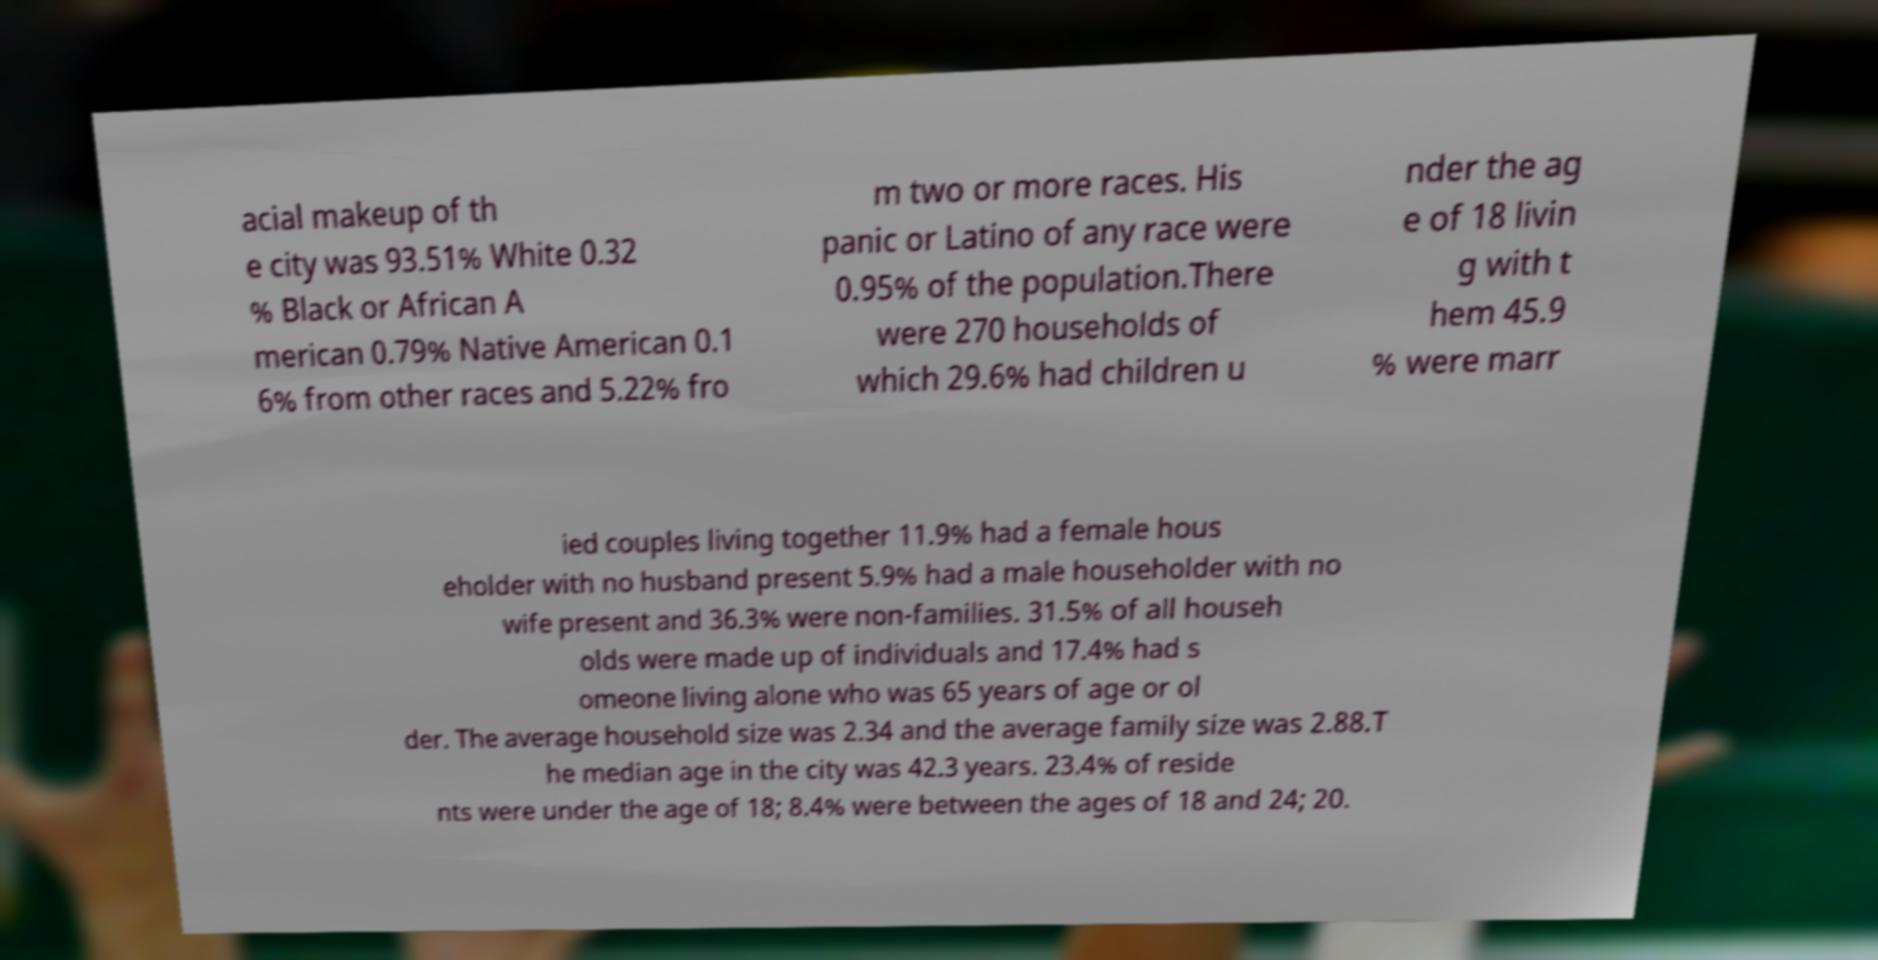There's text embedded in this image that I need extracted. Can you transcribe it verbatim? acial makeup of th e city was 93.51% White 0.32 % Black or African A merican 0.79% Native American 0.1 6% from other races and 5.22% fro m two or more races. His panic or Latino of any race were 0.95% of the population.There were 270 households of which 29.6% had children u nder the ag e of 18 livin g with t hem 45.9 % were marr ied couples living together 11.9% had a female hous eholder with no husband present 5.9% had a male householder with no wife present and 36.3% were non-families. 31.5% of all househ olds were made up of individuals and 17.4% had s omeone living alone who was 65 years of age or ol der. The average household size was 2.34 and the average family size was 2.88.T he median age in the city was 42.3 years. 23.4% of reside nts were under the age of 18; 8.4% were between the ages of 18 and 24; 20. 